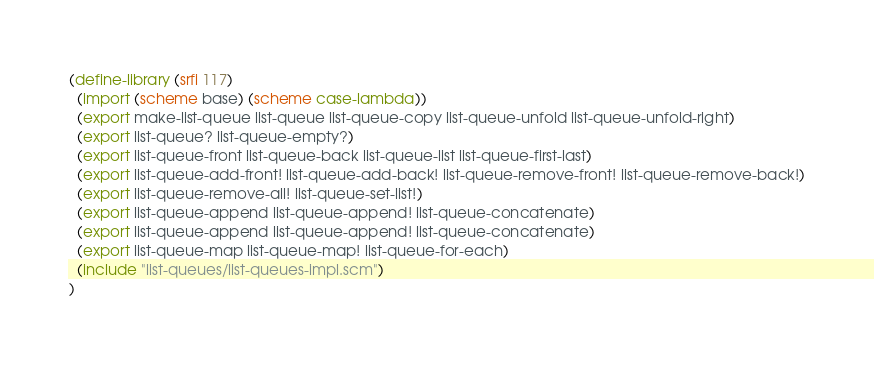<code> <loc_0><loc_0><loc_500><loc_500><_Scheme_>(define-library (srfi 117)
  (import (scheme base) (scheme case-lambda))
  (export make-list-queue list-queue list-queue-copy list-queue-unfold list-queue-unfold-right)
  (export list-queue? list-queue-empty?)
  (export list-queue-front list-queue-back list-queue-list list-queue-first-last)
  (export list-queue-add-front! list-queue-add-back! list-queue-remove-front! list-queue-remove-back!)
  (export list-queue-remove-all! list-queue-set-list!)
  (export list-queue-append list-queue-append! list-queue-concatenate)
  (export list-queue-append list-queue-append! list-queue-concatenate)
  (export list-queue-map list-queue-map! list-queue-for-each)
  (include "list-queues/list-queues-impl.scm")
)
</code> 